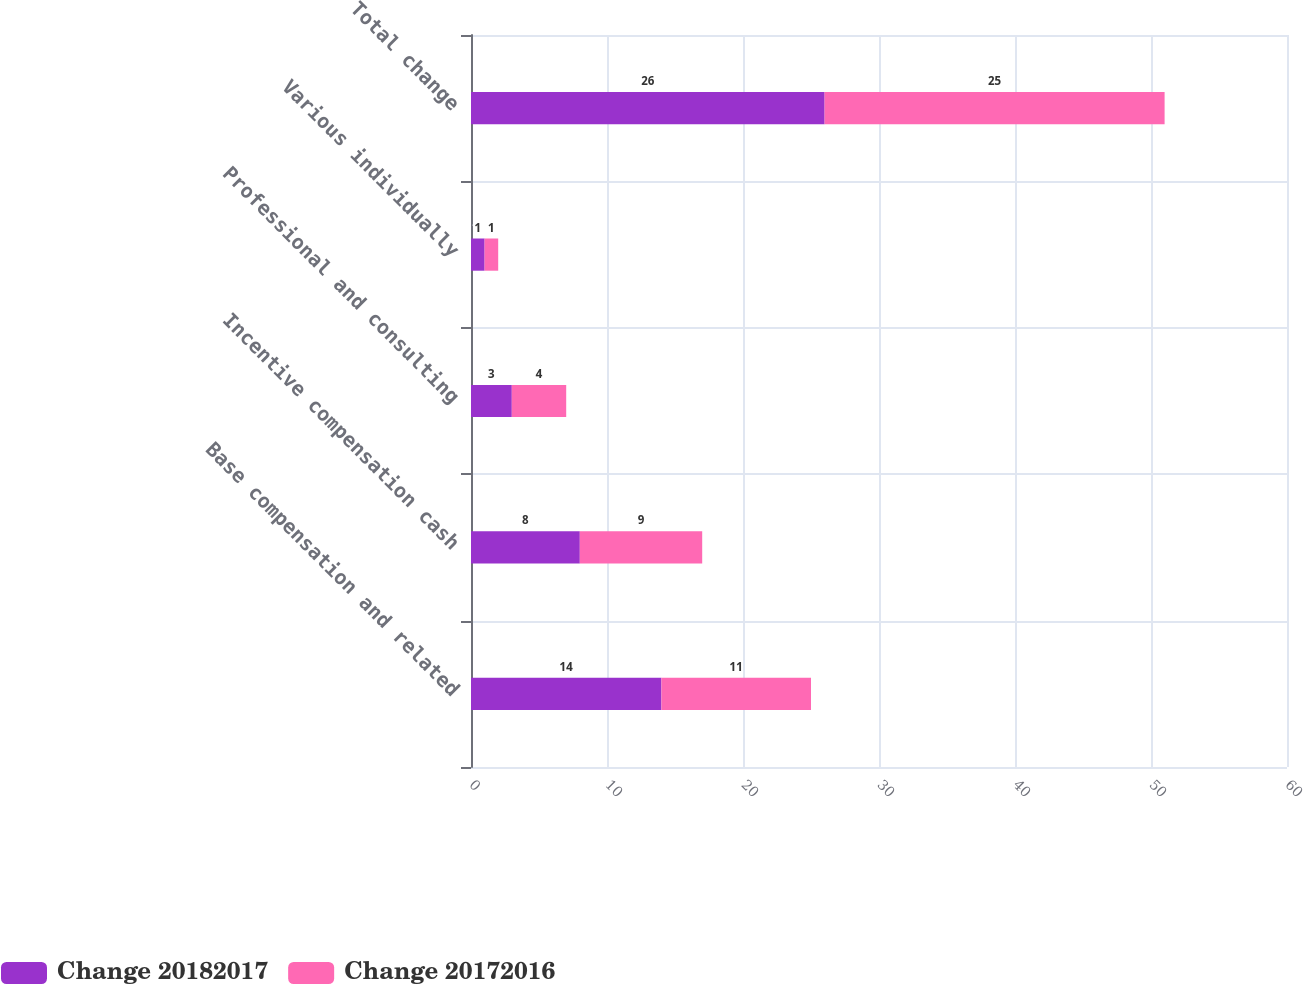Convert chart to OTSL. <chart><loc_0><loc_0><loc_500><loc_500><stacked_bar_chart><ecel><fcel>Base compensation and related<fcel>Incentive compensation cash<fcel>Professional and consulting<fcel>Various individually<fcel>Total change<nl><fcel>Change 20182017<fcel>14<fcel>8<fcel>3<fcel>1<fcel>26<nl><fcel>Change 20172016<fcel>11<fcel>9<fcel>4<fcel>1<fcel>25<nl></chart> 